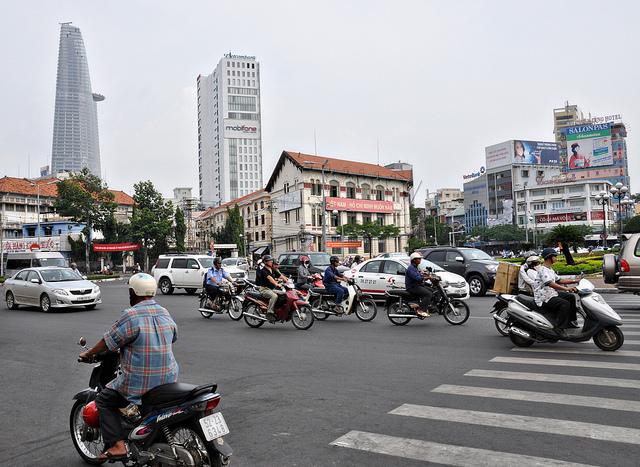Are all the motorcycle riders wearing helmets?
Keep it brief. Yes. How many cars are there?
Give a very brief answer. 6. How many motorcycles are there?
Be succinct. 7. Are there any line in the street?
Concise answer only. Yes. Do all the motorcycles have one rider?
Short answer required. Yes. 